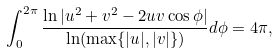<formula> <loc_0><loc_0><loc_500><loc_500>\int _ { 0 } ^ { 2 \pi } \frac { \ln | u ^ { 2 } + v ^ { 2 } - 2 u v \cos \phi | } { \ln ( \max \{ | u | , | v | \} ) } d \phi = 4 \pi ,</formula> 